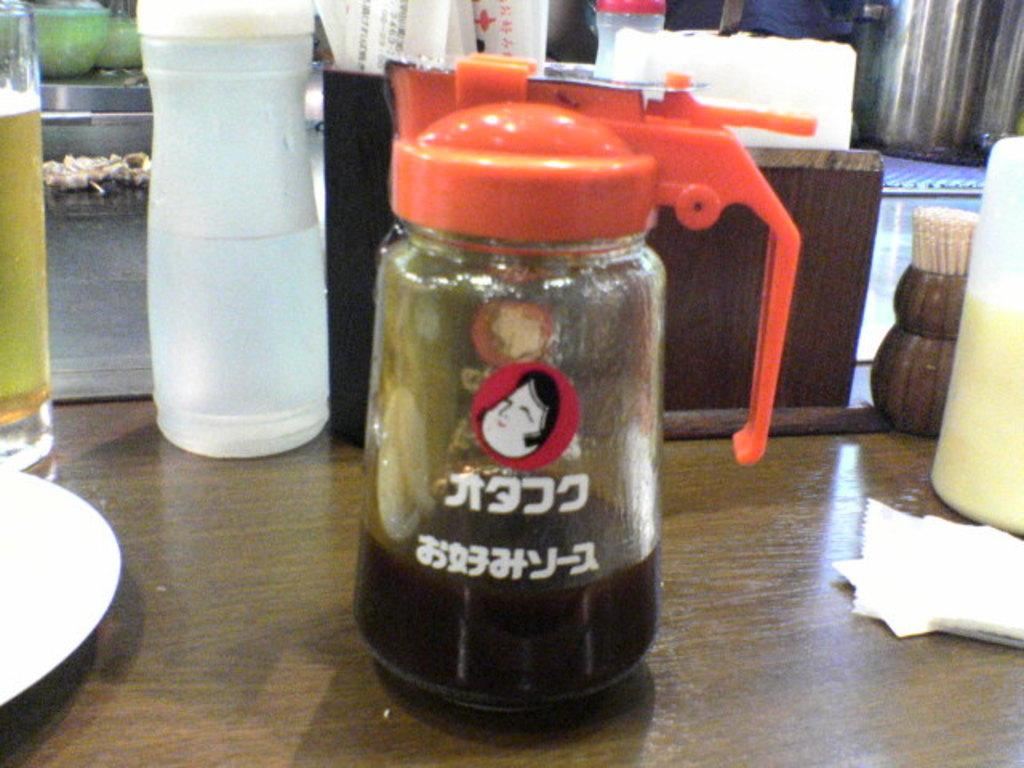Where was the image taken? The image was clicked inside. What can be seen on the table in the image? There are jars, bottles, and glasses on the table in the image. Can you describe the jars on the table? One of the jars has an orange color lid. What type of nose can be seen on the eggnog in the image? There is no eggnog present in the image, and therefore no nose can be seen on it. What color is the silverware in the image? There is no silverware present in the image. 